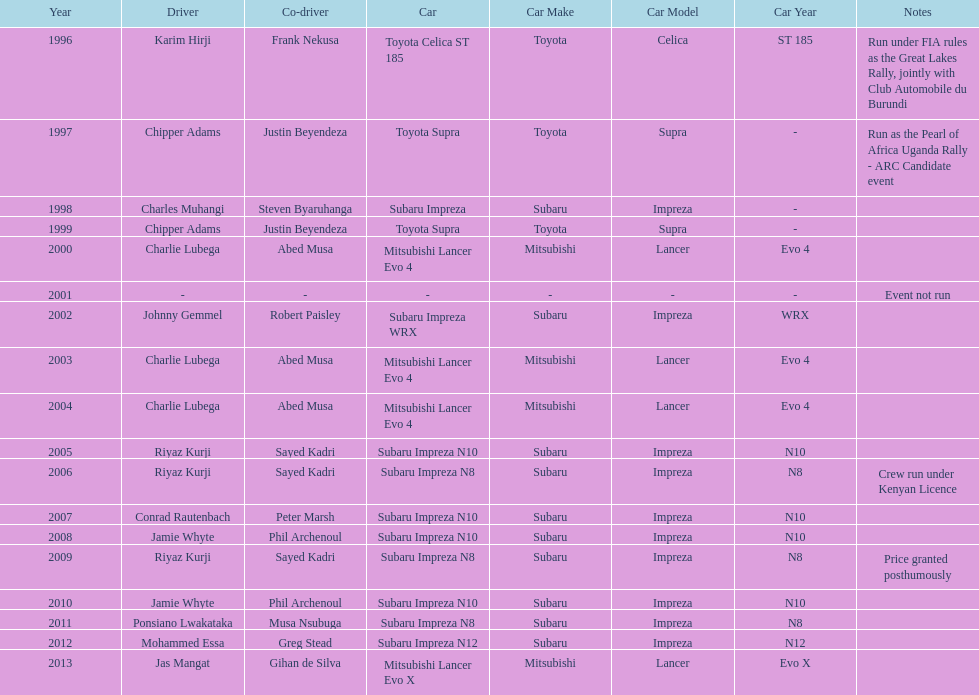How many times was a mitsubishi lancer the winning car before the year 2004? 2. 